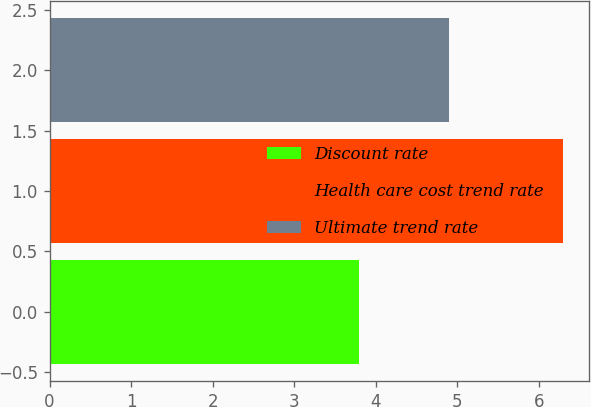<chart> <loc_0><loc_0><loc_500><loc_500><bar_chart><fcel>Discount rate<fcel>Health care cost trend rate<fcel>Ultimate trend rate<nl><fcel>3.8<fcel>6.3<fcel>4.9<nl></chart> 